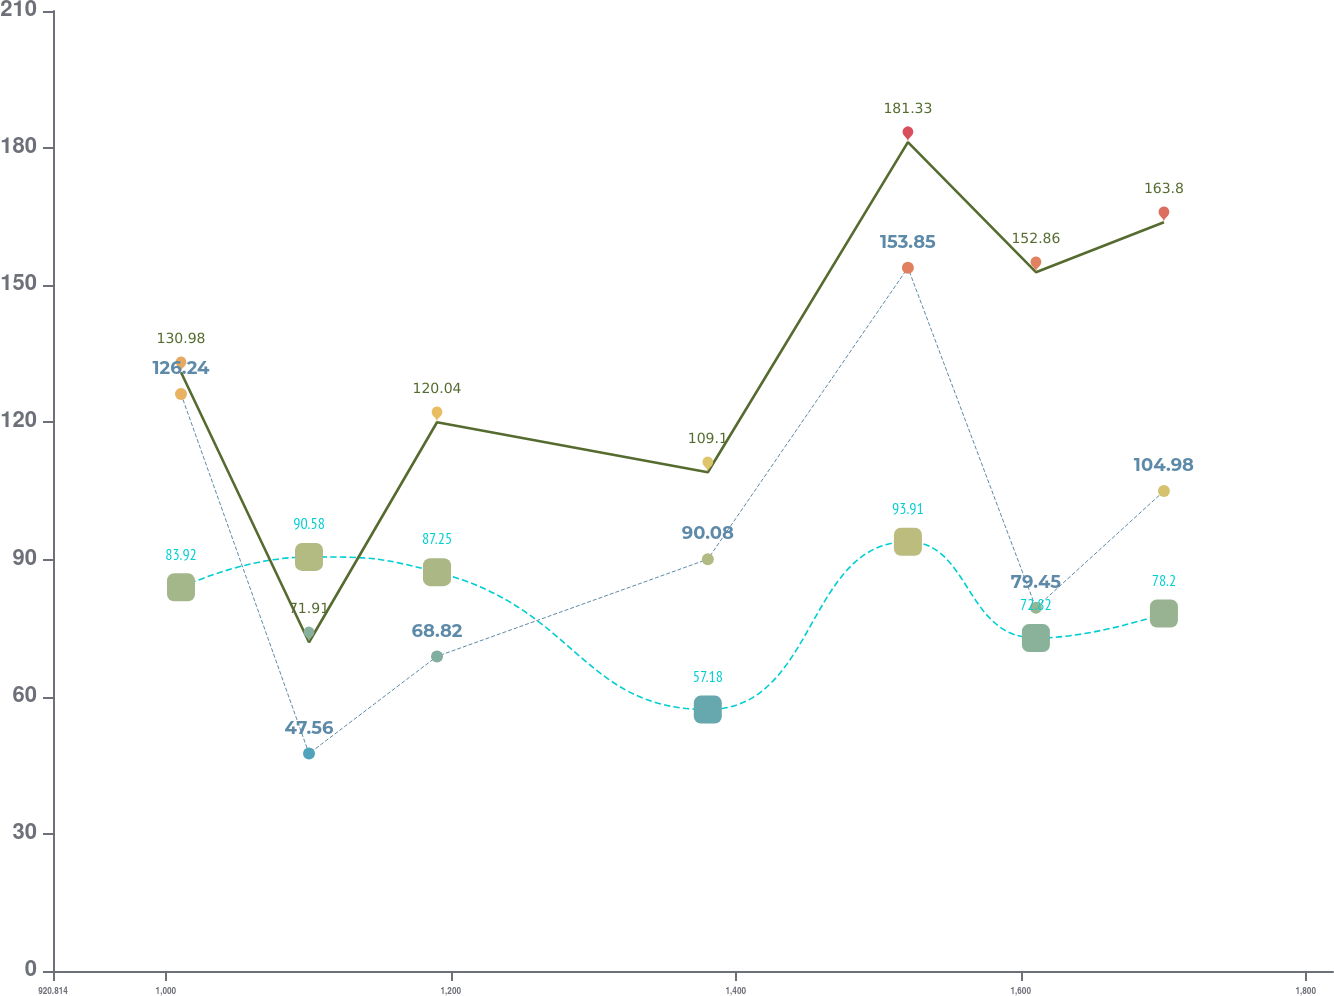Convert chart to OTSL. <chart><loc_0><loc_0><loc_500><loc_500><line_chart><ecel><fcel>Unnamed: 1<fcel>For Capital Adequacy<fcel>To Be Well Capitalized Under Prompt Corrective Action Provisions<nl><fcel>1010.65<fcel>83.92<fcel>126.24<fcel>130.98<nl><fcel>1100.49<fcel>90.58<fcel>47.56<fcel>71.91<nl><fcel>1190.33<fcel>87.25<fcel>68.82<fcel>120.04<nl><fcel>1380.39<fcel>57.18<fcel>90.08<fcel>109.1<nl><fcel>1520.83<fcel>93.91<fcel>153.85<fcel>181.33<nl><fcel>1610.67<fcel>72.82<fcel>79.45<fcel>152.86<nl><fcel>1700.51<fcel>78.2<fcel>104.98<fcel>163.8<nl><fcel>1909.01<fcel>66.23<fcel>115.61<fcel>141.92<nl></chart> 